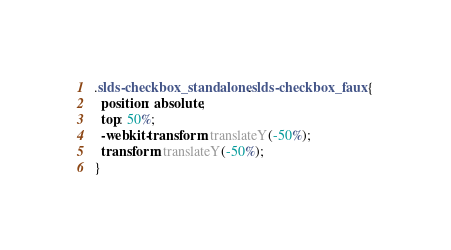Convert code to text. <code><loc_0><loc_0><loc_500><loc_500><_CSS_>.slds-checkbox_standalone .slds-checkbox_faux {
  position: absolute;
  top: 50%;
  -webkit-transform: translateY(-50%);
  transform: translateY(-50%);
}
</code> 